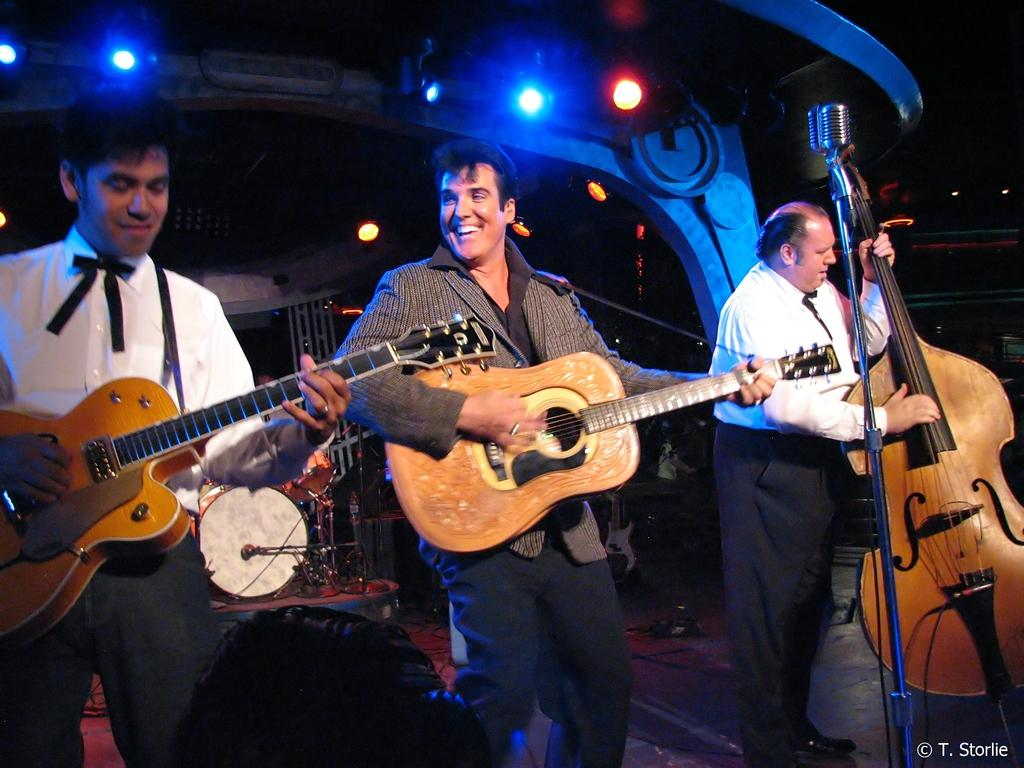How many people are in the group in the image? There is a group of people in the image. What are the people in the group doing? The people are standing and playing the guitar. What equipment is in front of the group? There is a microphone in front of the group. What other musical instruments can be seen in the image? There are musical drums visible in the image. What can be seen in the image that might provide illumination? There are lights in the image. What type of sand can be seen in the image? There is no sand present in the image. What time does the clock in the image show? There is no clock present in the image. 